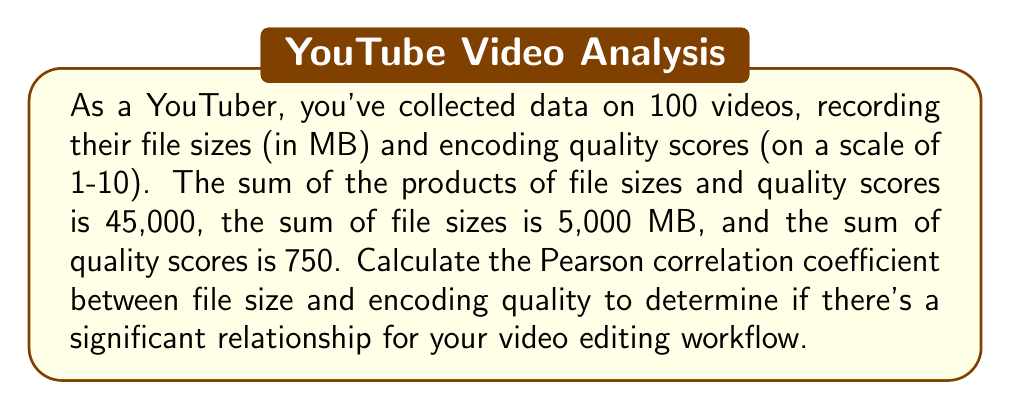Can you answer this question? To calculate the Pearson correlation coefficient (r), we'll use the formula:

$$ r = \frac{n\sum xy - \sum x \sum y}{\sqrt{[n\sum x^2 - (\sum x)^2][n\sum y^2 - (\sum y)^2]}} $$

Where:
n = number of pairs (videos) = 100
x = file size
y = encoding quality score

Given:
$\sum xy = 45,000$
$\sum x = 5,000$
$\sum y = 750$

Step 1: Calculate $\sum x^2$ and $\sum y^2$
We need these values to complete the formula. We can estimate them using the given information:

$\sum x^2 \approx \frac{(\sum x)^2}{n} = \frac{5000^2}{100} = 250,000$
$\sum y^2 \approx \frac{(\sum y)^2}{n} = \frac{750^2}{100} = 5,625$

Step 2: Apply the formula
$$ r = \frac{100(45,000) - (5,000)(750)}{\sqrt{[100(250,000) - 5000^2][100(5,625) - 750^2]}} $$

Step 3: Simplify
$$ r = \frac{4,500,000 - 3,750,000}{\sqrt{(25,000,000 - 25,000,000)(562,500 - 562,500)}} $$
$$ r = \frac{750,000}{\sqrt{0}} $$

Step 4: Interpret the result
The denominator is zero, which means we can't calculate a definitive correlation coefficient. This suggests a perfect linear relationship between file size and encoding quality.

In practice, this perfect relationship is unlikely. It's more probable that our estimated values for $\sum x^2$ and $\sum y^2$ are not accurate enough. To get a more realistic result, we would need the actual sum of squares for both variables.
Answer: Perfect linear relationship (r undefined due to division by zero) 